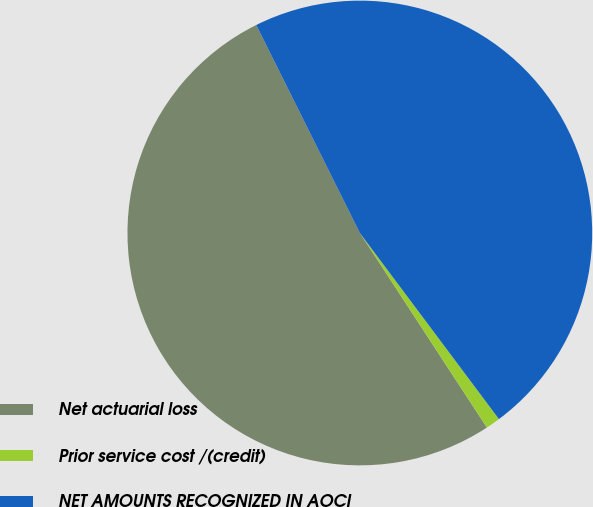Convert chart to OTSL. <chart><loc_0><loc_0><loc_500><loc_500><pie_chart><fcel>Net actuarial loss<fcel>Prior service cost /(credit)<fcel>NET AMOUNTS RECOGNIZED IN AOCI<nl><fcel>51.85%<fcel>1.01%<fcel>47.14%<nl></chart> 